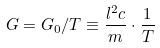Convert formula to latex. <formula><loc_0><loc_0><loc_500><loc_500>G = G _ { 0 } / T \equiv \frac { l ^ { 2 } c } { m } \cdot \frac { 1 } { T }</formula> 